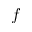<formula> <loc_0><loc_0><loc_500><loc_500>f</formula> 